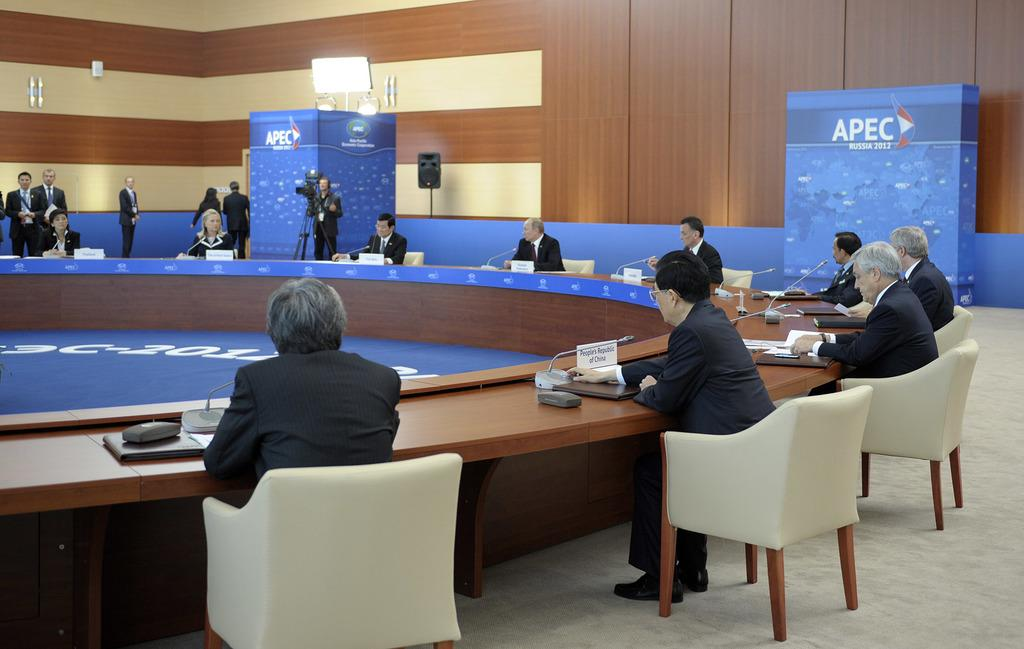What are the people in the image doing? The people in the image are sitting on chairs around the table. What objects can be seen on the table? There are phones, a mug, and a poster on the table. What is the color of the floor in the image? The floor is white in color. What type of fruit is being used as a leveling tool in the image? There is no fruit present in the image, nor is there any indication of a leveling tool being used. 